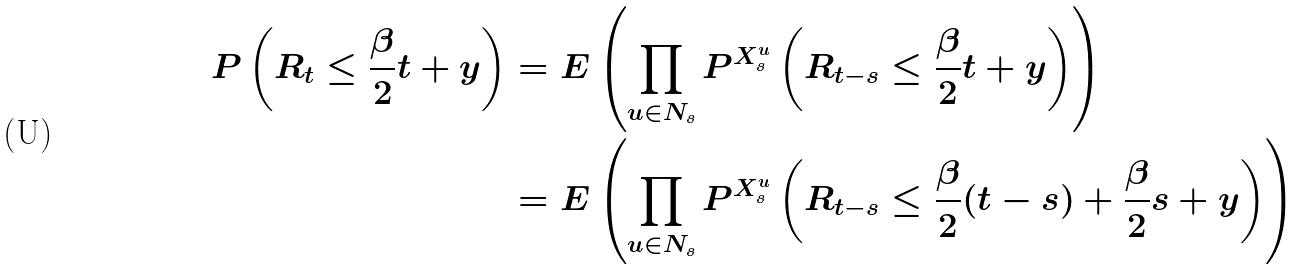Convert formula to latex. <formula><loc_0><loc_0><loc_500><loc_500>P \left ( R _ { t } \leq \frac { \beta } { 2 } t + y \right ) & = E \left ( \prod _ { u \in N _ { s } } P ^ { X ^ { u } _ { s } } \left ( R _ { t - s } \leq \frac { \beta } { 2 } t + y \right ) \right ) \\ & = E \left ( \prod _ { u \in N _ { s } } P ^ { X ^ { u } _ { s } } \left ( R _ { t - s } \leq \frac { \beta } { 2 } ( t - s ) + \frac { \beta } { 2 } s + y \right ) \right )</formula> 